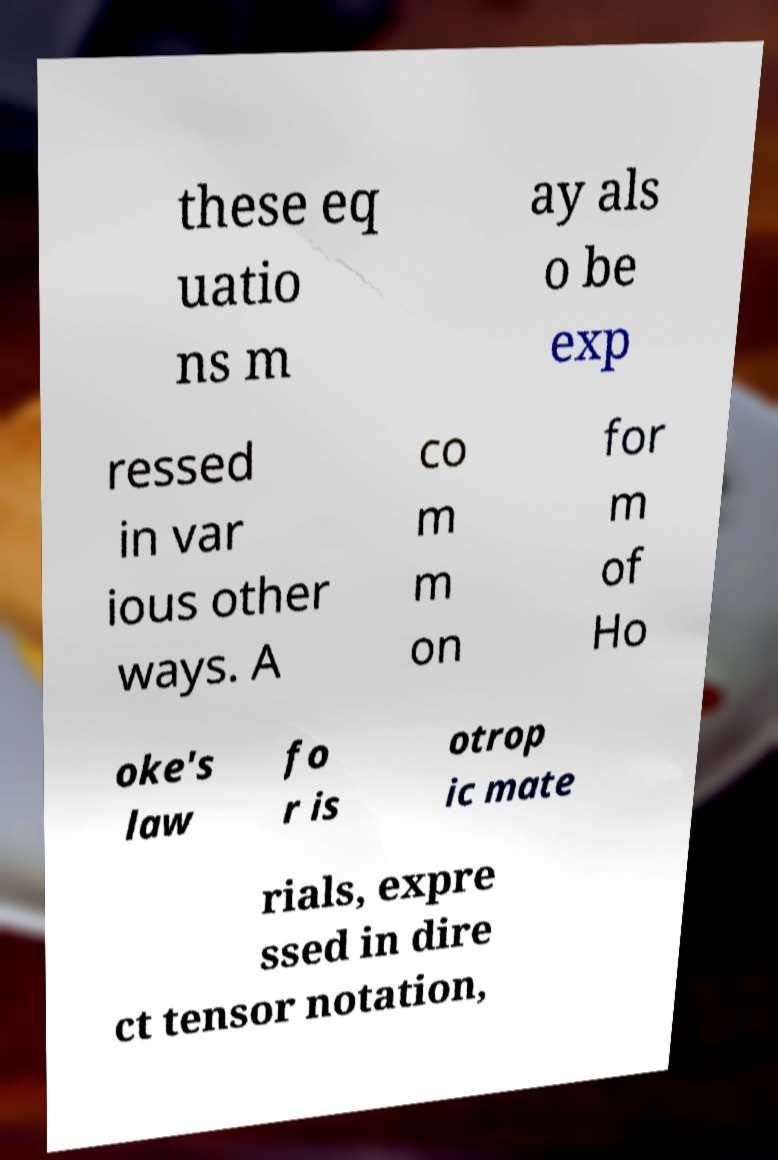Can you accurately transcribe the text from the provided image for me? these eq uatio ns m ay als o be exp ressed in var ious other ways. A co m m on for m of Ho oke's law fo r is otrop ic mate rials, expre ssed in dire ct tensor notation, 